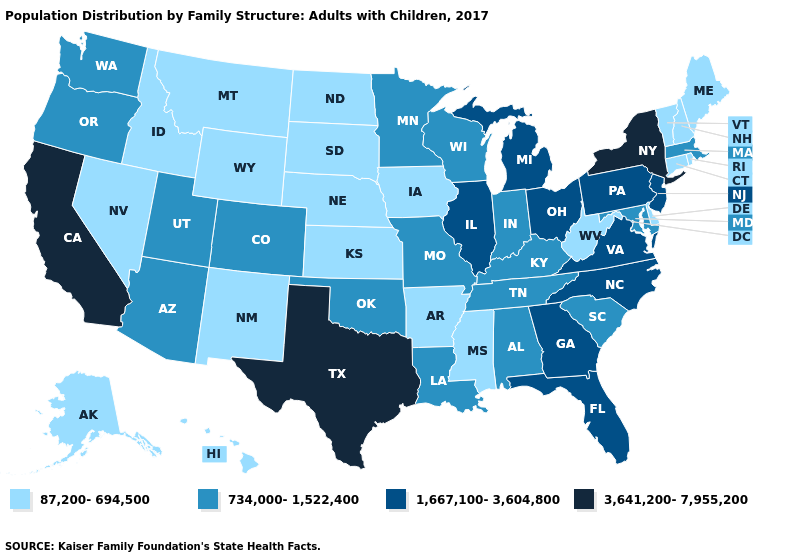Which states hav the highest value in the MidWest?
Short answer required. Illinois, Michigan, Ohio. Name the states that have a value in the range 734,000-1,522,400?
Concise answer only. Alabama, Arizona, Colorado, Indiana, Kentucky, Louisiana, Maryland, Massachusetts, Minnesota, Missouri, Oklahoma, Oregon, South Carolina, Tennessee, Utah, Washington, Wisconsin. Which states hav the highest value in the MidWest?
Write a very short answer. Illinois, Michigan, Ohio. Does the first symbol in the legend represent the smallest category?
Quick response, please. Yes. Which states have the lowest value in the USA?
Concise answer only. Alaska, Arkansas, Connecticut, Delaware, Hawaii, Idaho, Iowa, Kansas, Maine, Mississippi, Montana, Nebraska, Nevada, New Hampshire, New Mexico, North Dakota, Rhode Island, South Dakota, Vermont, West Virginia, Wyoming. What is the lowest value in states that border North Carolina?
Give a very brief answer. 734,000-1,522,400. Which states have the lowest value in the South?
Keep it brief. Arkansas, Delaware, Mississippi, West Virginia. Name the states that have a value in the range 87,200-694,500?
Be succinct. Alaska, Arkansas, Connecticut, Delaware, Hawaii, Idaho, Iowa, Kansas, Maine, Mississippi, Montana, Nebraska, Nevada, New Hampshire, New Mexico, North Dakota, Rhode Island, South Dakota, Vermont, West Virginia, Wyoming. Does the map have missing data?
Concise answer only. No. Name the states that have a value in the range 1,667,100-3,604,800?
Concise answer only. Florida, Georgia, Illinois, Michigan, New Jersey, North Carolina, Ohio, Pennsylvania, Virginia. Name the states that have a value in the range 3,641,200-7,955,200?
Concise answer only. California, New York, Texas. What is the value of Kentucky?
Short answer required. 734,000-1,522,400. Does the map have missing data?
Keep it brief. No. Name the states that have a value in the range 734,000-1,522,400?
Answer briefly. Alabama, Arizona, Colorado, Indiana, Kentucky, Louisiana, Maryland, Massachusetts, Minnesota, Missouri, Oklahoma, Oregon, South Carolina, Tennessee, Utah, Washington, Wisconsin. Does West Virginia have the lowest value in the South?
Concise answer only. Yes. 